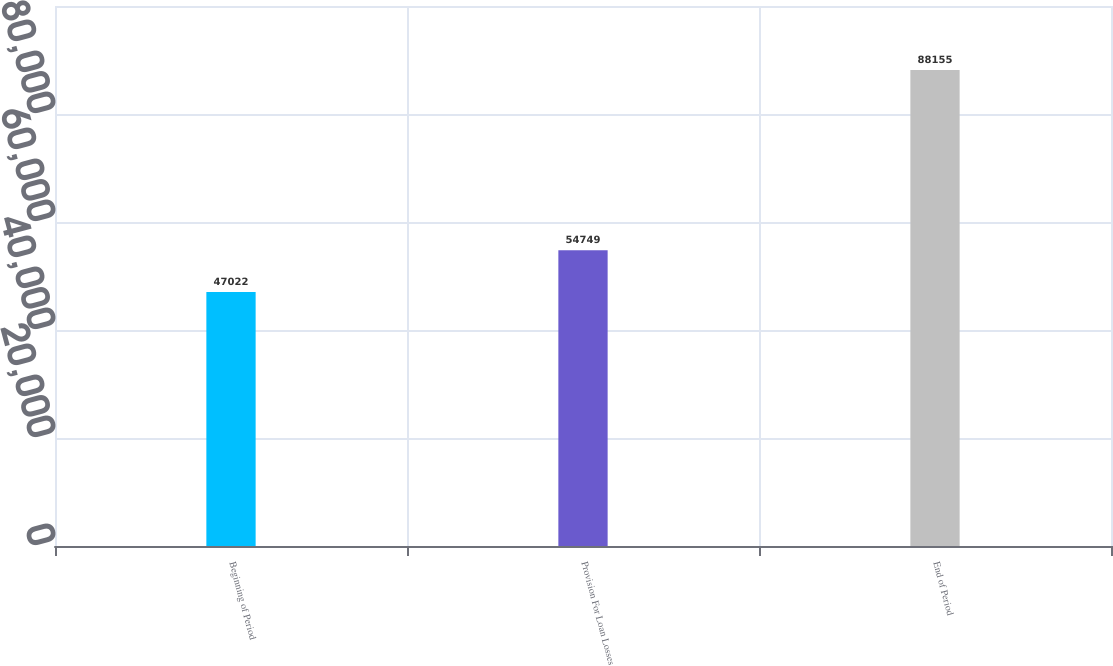Convert chart. <chart><loc_0><loc_0><loc_500><loc_500><bar_chart><fcel>Beginning of Period<fcel>Provision For Loan Losses<fcel>End of Period<nl><fcel>47022<fcel>54749<fcel>88155<nl></chart> 